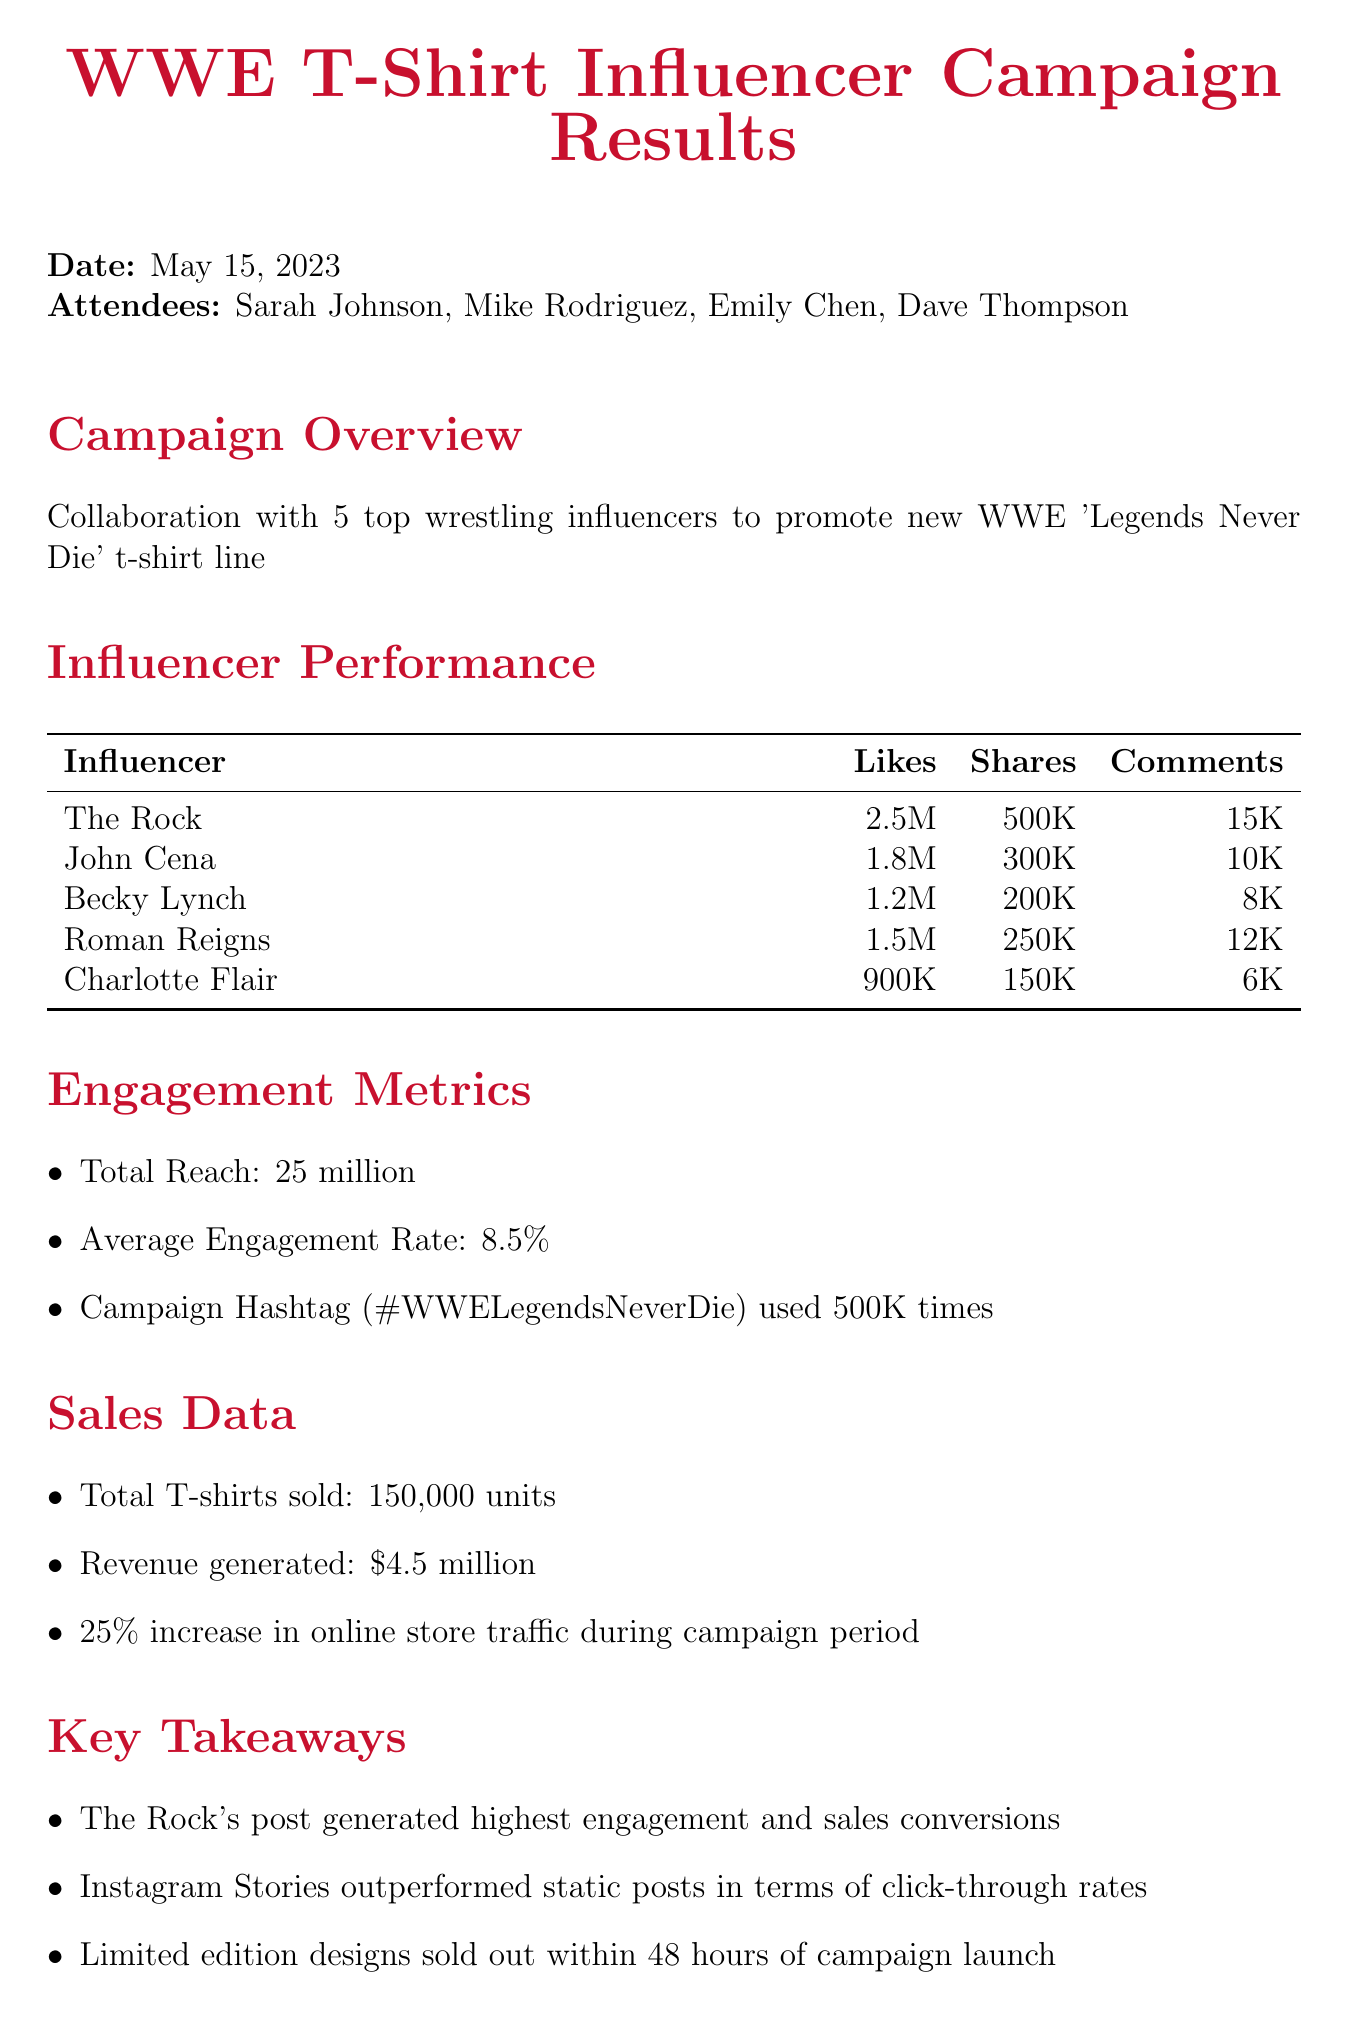what was the date of the meeting? The date of the meeting is explicitly stated in the document.
Answer: May 15, 2023 how many influencers were involved in the campaign? The document specifies the number of influencers who collaborated in the campaign.
Answer: 5 who generated the highest engagement? The key takeaways highlight which influencer achieved the highest engagement level.
Answer: The Rock what was the total reach of the campaign? The engagement metrics section provides the total reach figure for the campaign.
Answer: 25 million what percentage increase in online store traffic was observed? The sales data section mentions the percentage increase in online store traffic.
Answer: 25% how many total t-shirts were sold? The sales data explicitly indicates the number of t-shirts sold during the campaign.
Answer: 150,000 which social media platform's format outperformed others? The key takeaways contain information on which format had better performance.
Answer: Instagram Stories what was the total revenue generated from sales? The sales data section provides the total revenue generated during the campaign.
Answer: 4.5 million what is the next step regarding influencer campaigns? The next steps outline potential actions moving forward, particularly related to influencers.
Answer: Plan follow-up campaign with top-performing influencers 